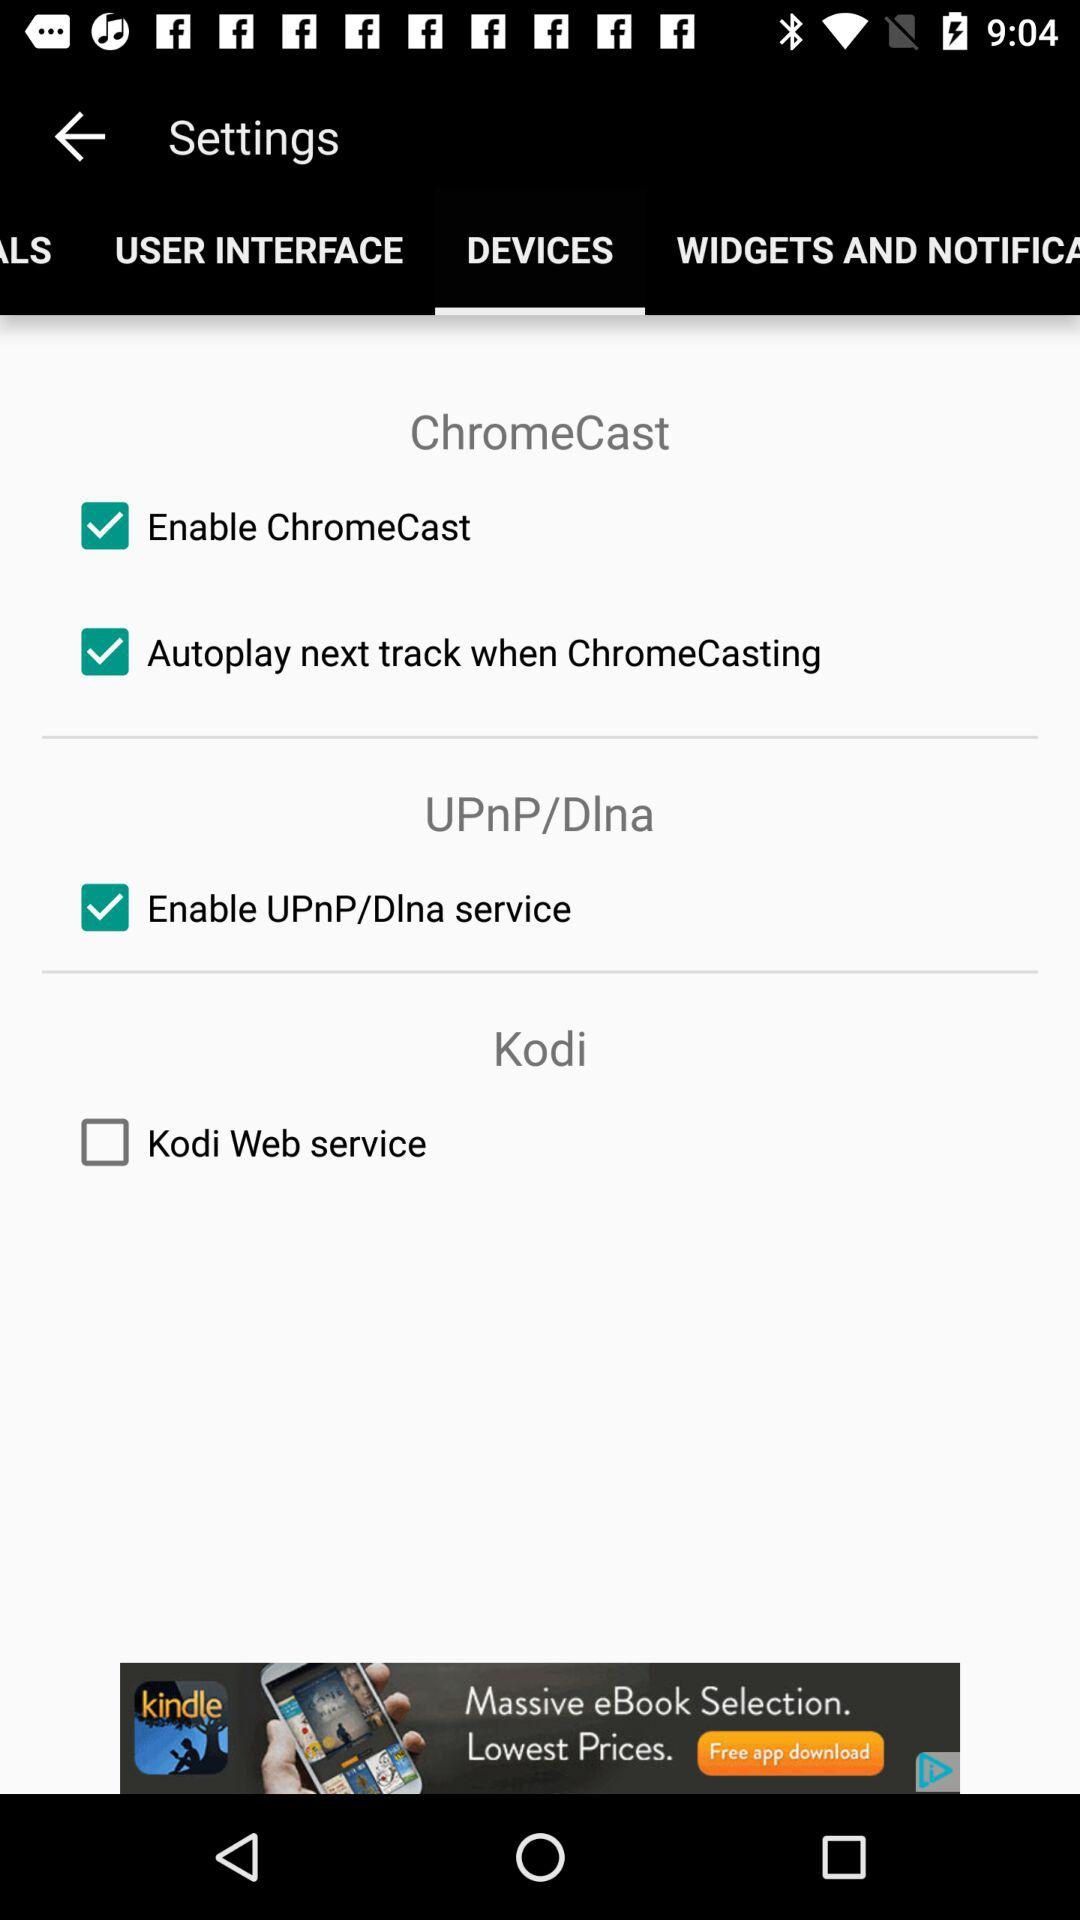What is the status of "Autoplay next track when ChromeCasting"? The status is "on". 